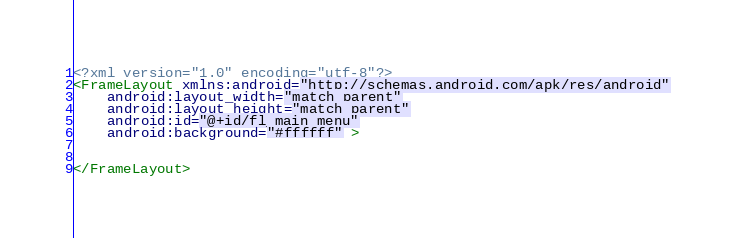<code> <loc_0><loc_0><loc_500><loc_500><_XML_><?xml version="1.0" encoding="utf-8"?>
<FrameLayout xmlns:android="http://schemas.android.com/apk/res/android"
    android:layout_width="match_parent"
    android:layout_height="match_parent"
    android:id="@+id/fl_main_menu"
    android:background="#ffffff" >
    

</FrameLayout>
</code> 